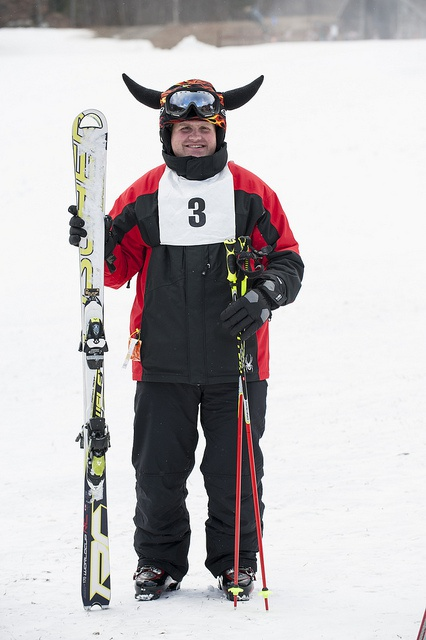Describe the objects in this image and their specific colors. I can see people in gray, black, lightgray, and brown tones and skis in gray, lightgray, black, and darkgray tones in this image. 